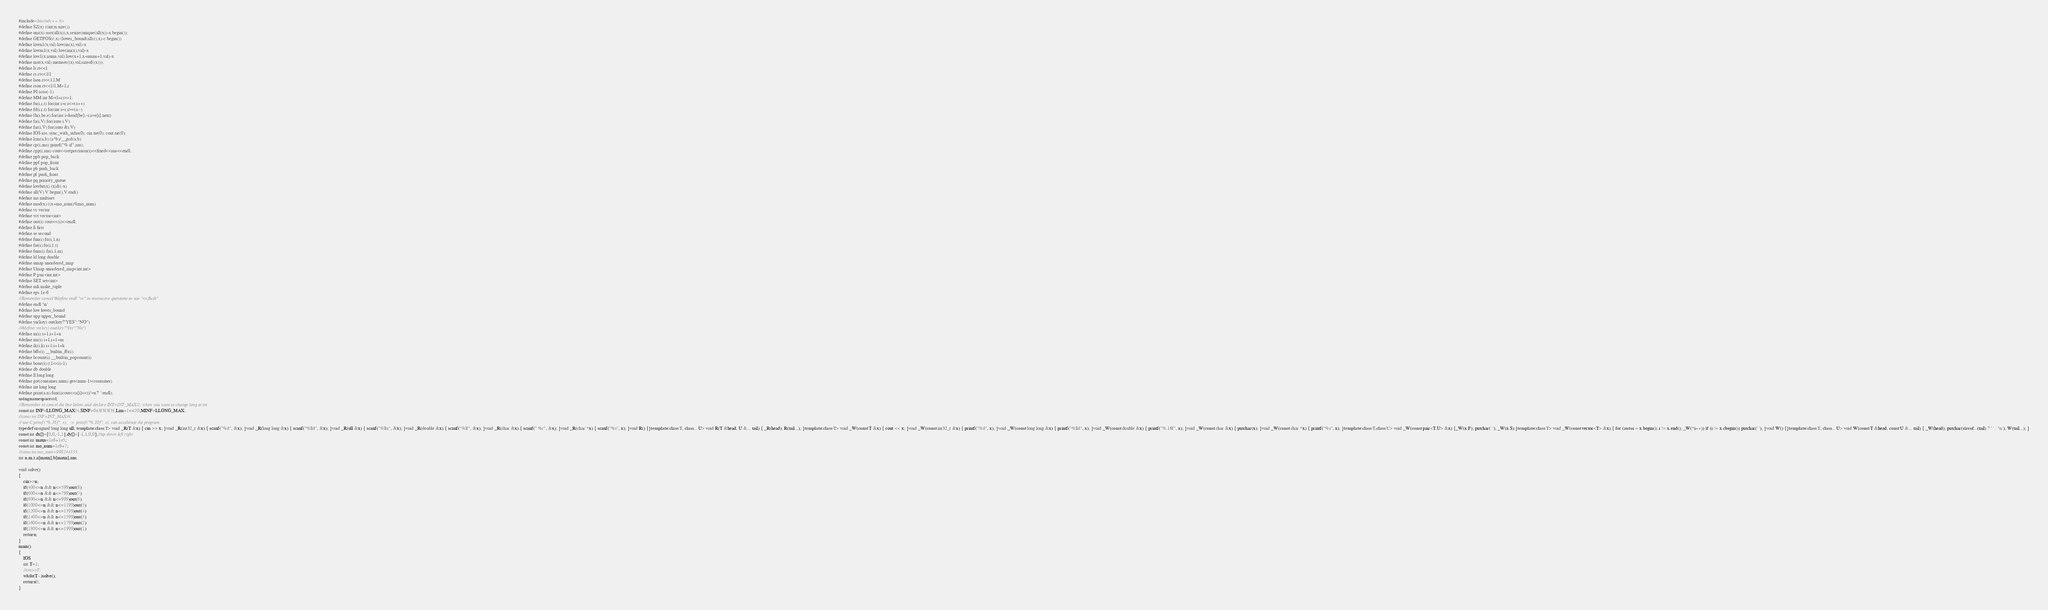Convert code to text. <code><loc_0><loc_0><loc_500><loc_500><_C++_>#include<bits/stdc++.h>
#define SZ(x) ((int)x.size())
#define uni(x) sort(all(x)),x.resize(unique(all(x))-x.begin());
#define GETPOS(c,x) (lower_bound(all(c),x)-c.begin())
#define lown1(x,val) low(in(x),val)-x
#define lowm1(x,val) low(im(x),val)-x
#define low1(x,nums,val) low(x+1,x+nums+1,val)-x
#define mst(x,val) memset((x),val,sizeof((x)));
#define ls rt<<1
#define rs rt<<1|1
#define lson rt<<1,l,M
#define rson rt<<1|1,M+1,r
#define PI acos(-1)
#define MM int M=(l+r)>>1;
#define fu(i,r,t) for(int i=r;i<=t;i++)
#define fd(i,r,t) for(int i=r;i>=t;i--)
#define fh(i,be,e) for(int i=head[be];~i;i=e[i].next)
#define fa(i,V) for(auto i:V)
#define far(i,V) for(auto &i:V)
#define IOS ios::sync_with_stdio(0); cin.tie(0); cout.tie(0);
#define lcm(a,b) (a*b)/__gcd(a,b)
#define cp(i,ans) printf("%.if",ans);
#define cpp(i,ans) cout<<setprecision(i)<<fixed<<ans<<endl;
#define ppb pop_back
#define ppf pop_front
#define pb push_back
#define pf push_front
#define pq priority_queue
#define lowbit(x) (x)&(-x)
#define all(V) V.begin(),V.end()
#define ms multiset
#define mod(x) ((x+mo_num)%mo_num)
#define vc vector
#define vct vector<int>
#define out(i) cout<<(i)<<endl;
#define fi first
#define se second
#define fun(i) fu(i,1,n)
#define fut(i) fu(i,1,t)
#define fum(i) fu(i,1,m)
#define ld long double
#define umap unordered_map
#define Umap unordered_map<int,int>
#define P pair<int,int>
#define SET set<int>
#define mk make_tuple
#define eps 1e-6
//Remember cancel"#define endl '\n'" in interactive questions or use "<<flush"
#define endl '\n'
#define low lower_bound
#define upp upper_bound
#define yn(key) out(key?"YES":"NO")
//#define yn(key) out(key?"Yes":"No")
#define in(i) i+1,i+1+n
#define im(i) i+1,i+1+m
#define ik(i,k) i+1,i+1+k
#define bffs(i) __builtin_ffs(i)
#define bcount(i) __builtin_popcount(i)
#define bone(i) ((1<<i)-1)
#define db double
#define ll long long
#define got(container,num) get<num-1>(container)
#define int long long
#define print(a,n) fun(i)cout<<a[i]<<(i!=n?' ':endl);
using namespace std;
//Remember to cancel the line below and declare INT=INT_MAX/2; when you want to change long to int
const int INF=LLONG_MAX/4,SINF=0x3f3f3f3f,Lim=1<<20,MINF=LLONG_MAX;
//const int INF=INT_MAX/4;
// use C:printf("%.16f", x);  ->  printf("%.10f", x); can accelerate the program
typedef unsigned long long ull; template<class T> void _R(T &x) { cin >> x; }void _R(int32_t &x) { scanf("%d", &x); }void _R(long long &x) { scanf("%lld", &x); }void _R(ull &x) { scanf("%llu", &x); }void _R(double &x) { scanf("%lf", &x); }void _R(char &x) { scanf(" %c", &x); }void _R(char *x) { scanf("%s", x); }void R() {}template<class T, class... U> void R(T &head, U &... tail) { _R(head); R(tail...); }template<class T> void _W(const T &x) { cout << x; }void _W(const int32_t &x) { printf("%d", x); }void _W(const long long &x) { printf("%lld", x); }void _W(const double &x) { printf("%.16f", x); }void _W(const char &x) { putchar(x); }void _W(const char *x) { printf("%s", x); }template<class T,class U> void _W(const pair<T,U> &x) {_W(x.F); putchar(' '); _W(x.S);}template<class T> void _W(const vector<T> &x) { for (auto i = x.begin(); i != x.end(); _W(*i++)) if (i != x.cbegin()) putchar(' '); }void W() {}template<class T, class... U> void W(const T &head, const U &... tail) { _W(head); putchar(sizeof...(tail) ? ' ' : '\n'); W(tail...); }
const int dx[]={0,0,-1,1},dy[]={-1,1,0,0};//up down left right
const int maxn=1e6+1e5;
const int mo_num=1e9+7;
//const int mo_num=998244353;
int n,m,t,a[maxn],b[maxn],ans;

void solve()
{
    cin>>n;
    if(400<=n && n<=599)out(8)
    if(600<=n && n<=799)out(7)
    if(800<=n && n<=999)out(6)
    if(1000<=n && n<=1199)out(5)
    if(1200<=n && n<=1399)out(4)
    if(1400<=n && n<=1599)out(3)
    if(1600<=n && n<=1799)out(2)
    if(1800<=n && n<=1999)out(1)
    return ;
}
main()
{
    IOS
    int T=1;
    //cin>>T;
    while(T--)solve();
    return 0;
}
</code> 